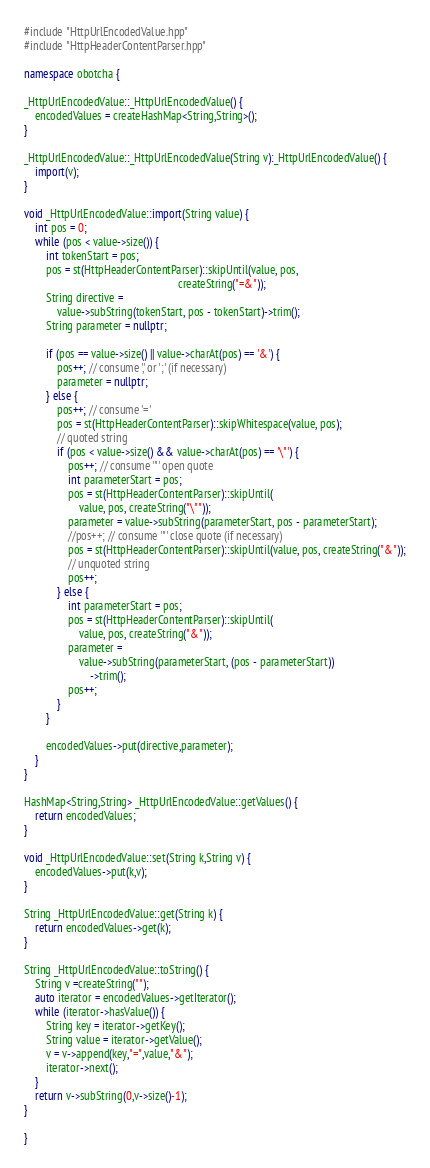<code> <loc_0><loc_0><loc_500><loc_500><_C++_>#include "HttpUrlEncodedValue.hpp"
#include "HttpHeaderContentParser.hpp"

namespace obotcha {

_HttpUrlEncodedValue::_HttpUrlEncodedValue() {
    encodedValues = createHashMap<String,String>();
}

_HttpUrlEncodedValue::_HttpUrlEncodedValue(String v):_HttpUrlEncodedValue() {
    import(v);
}

void _HttpUrlEncodedValue::import(String value) {
    int pos = 0;
    while (pos < value->size()) {
        int tokenStart = pos;
        pos = st(HttpHeaderContentParser)::skipUntil(value, pos,
                                                        createString("=&"));
        String directive =
            value->subString(tokenStart, pos - tokenStart)->trim();
        String parameter = nullptr;

        if (pos == value->size() || value->charAt(pos) == '&') {
            pos++; // consume ',' or ';' (if necessary)
            parameter = nullptr;
        } else {
            pos++; // consume '='
            pos = st(HttpHeaderContentParser)::skipWhitespace(value, pos);
            // quoted string
            if (pos < value->size() && value->charAt(pos) == '\"') {
                pos++; // consume '"' open quote
                int parameterStart = pos;
                pos = st(HttpHeaderContentParser)::skipUntil(
                    value, pos, createString("\""));
                parameter = value->subString(parameterStart, pos - parameterStart);
                //pos++; // consume '"' close quote (if necessary)
                pos = st(HttpHeaderContentParser)::skipUntil(value, pos, createString("&"));
                // unquoted string
                pos++;
            } else {
                int parameterStart = pos;
                pos = st(HttpHeaderContentParser)::skipUntil(
                    value, pos, createString("&"));
                parameter =
                    value->subString(parameterStart, (pos - parameterStart))
                        ->trim();
                pos++;
            }
        }

        encodedValues->put(directive,parameter);
    }
}

HashMap<String,String> _HttpUrlEncodedValue::getValues() {
    return encodedValues;
}

void _HttpUrlEncodedValue::set(String k,String v) {
    encodedValues->put(k,v);
}

String _HttpUrlEncodedValue::get(String k) {
    return encodedValues->get(k);
}

String _HttpUrlEncodedValue::toString() {
    String v =createString("");
    auto iterator = encodedValues->getIterator();
    while (iterator->hasValue()) {
        String key = iterator->getKey();
        String value = iterator->getValue();
        v = v->append(key,"=",value,"&");
        iterator->next();
    }
    return v->subString(0,v->size()-1);
}

}

</code> 